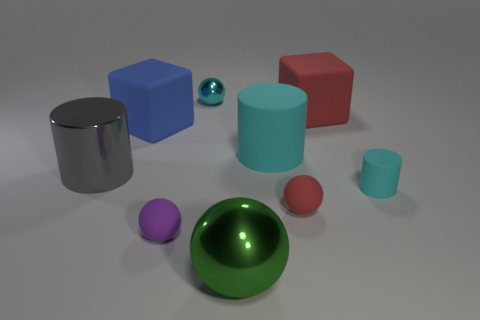How many large green rubber cubes are there?
Your answer should be very brief. 0. Do the cyan cylinder in front of the large cyan thing and the small red thing have the same material?
Offer a terse response. Yes. Is there a cyan object of the same size as the shiny cylinder?
Ensure brevity in your answer.  Yes. There is a blue matte thing; is it the same shape as the red matte object that is behind the blue block?
Give a very brief answer. Yes. There is a block that is to the left of the big metal object to the right of the purple object; are there any big cyan things in front of it?
Offer a terse response. Yes. How big is the green metallic object?
Provide a succinct answer. Large. How many other objects are there of the same color as the tiny cylinder?
Your answer should be very brief. 2. Is the shape of the tiny object that is behind the tiny rubber cylinder the same as  the purple matte object?
Offer a very short reply. Yes. There is another rubber thing that is the same shape as the large blue rubber thing; what color is it?
Give a very brief answer. Red. There is another purple object that is the same shape as the tiny shiny object; what is its size?
Offer a very short reply. Small. 